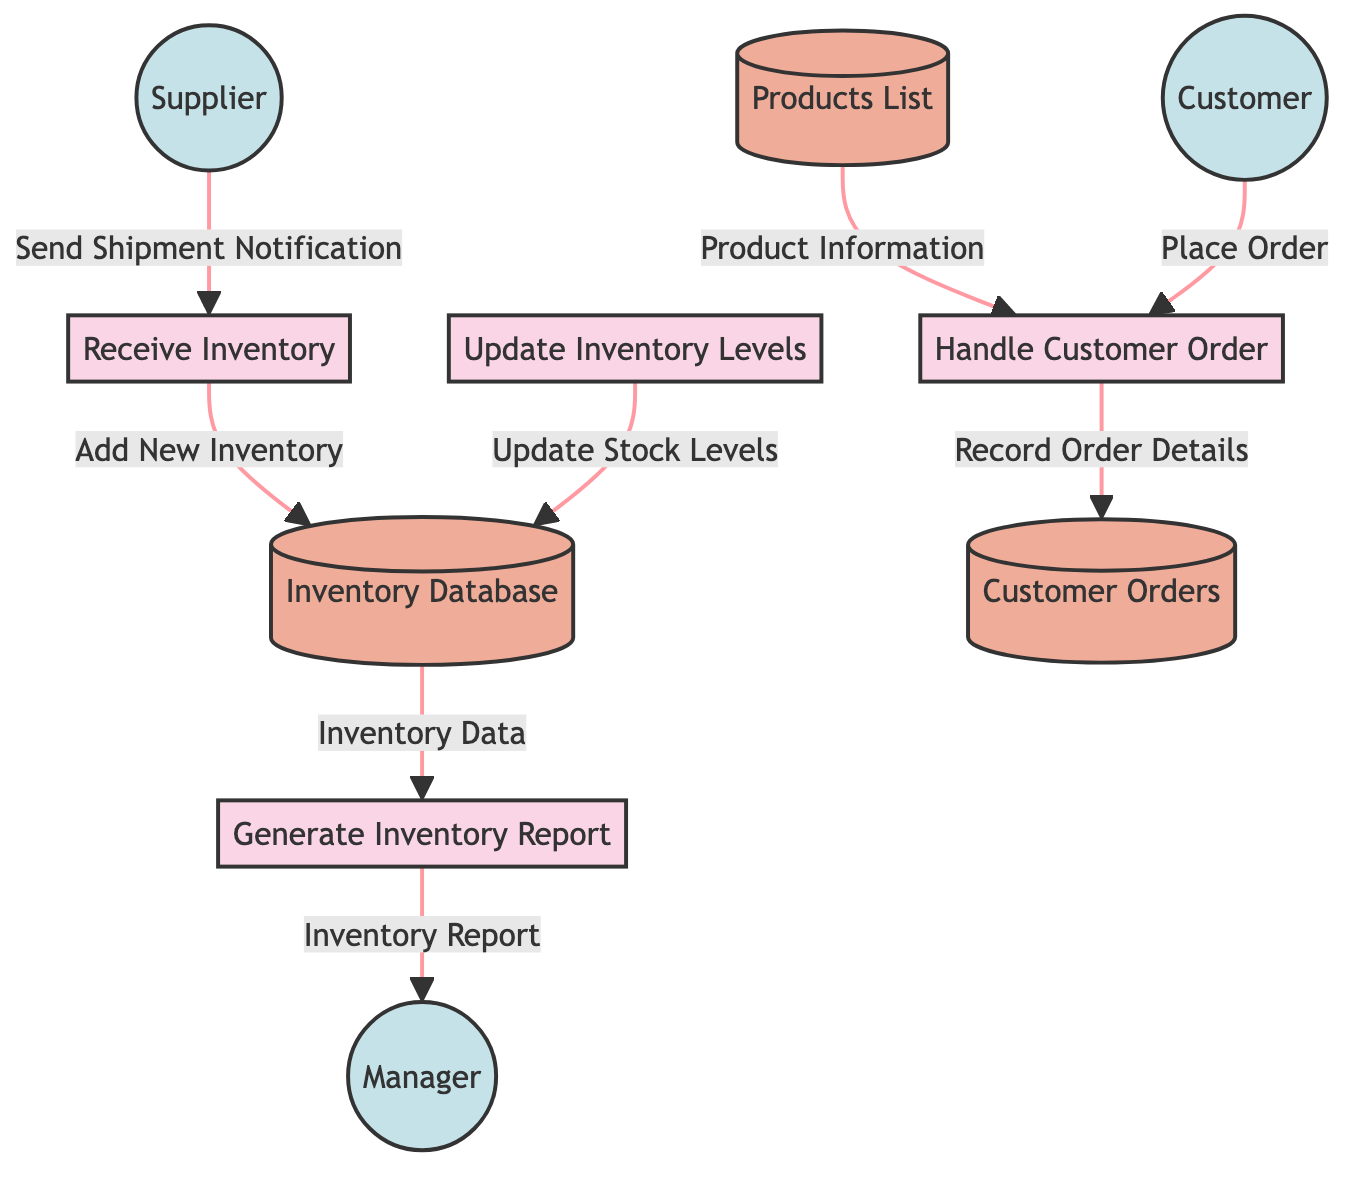What are the names of all processes in the diagram? The diagram includes four processes: Receive Inventory, Update Inventory Levels, Generate Inventory Report, and Handle Customer Order. Counting each label from the process nodes confirms this.
Answer: Receive Inventory, Update Inventory Levels, Generate Inventory Report, Handle Customer Order How many external entities are present in the diagram? By examining the diagram, we can identify three external entities: Supplier, Customer, and Manager. Counting each entity in the external nodes confirms this.
Answer: 3 Which process handles customer orders? The process handling customer orders is identified as "Handle Customer Order" in the diagram. Directly referencing the relevant process node provides this answer.
Answer: Handle Customer Order What data flow originates from the Customer? The data flow that originates from the Customer is labeled "Place Order", directed towards the "Handle Customer Order" process. Checking the source and destination nodes confirms this.
Answer: Place Order What is added to the Inventory Database after receiving inventory? The data flow indicates "Add New Inventory" is the action taken to add items to the Inventory Database after receiving inventory. This is captured in the respective flow line connecting Receive Inventory to Inventory Database.
Answer: Add New Inventory What type of report is generated for the Manager? The diagram specifies that an "Inventory Report" is generated for the Manager from the process of generating inventory reports. Referencing the flow from Generate Inventory Report to Manager provides this detail.
Answer: Inventory Report How many data stores are shown in the diagram? There are three data stores within the diagram: Inventory Database, Products List, and Customer Orders. Counting each data store node confirms this.
Answer: 3 What information is updated in the Inventory Database? The information that is updated in the Inventory Database is labeled as "Update Stock Levels". This is indicated in the flow from Update Inventory Levels to Inventory Database.
Answer: Update Stock Levels Which external entity sends a shipment notification? The shipment notification is sent by the external entity "Supplier" to the process "Receive Inventory". This is verified by checking the originating flow in the diagram.
Answer: Supplier 